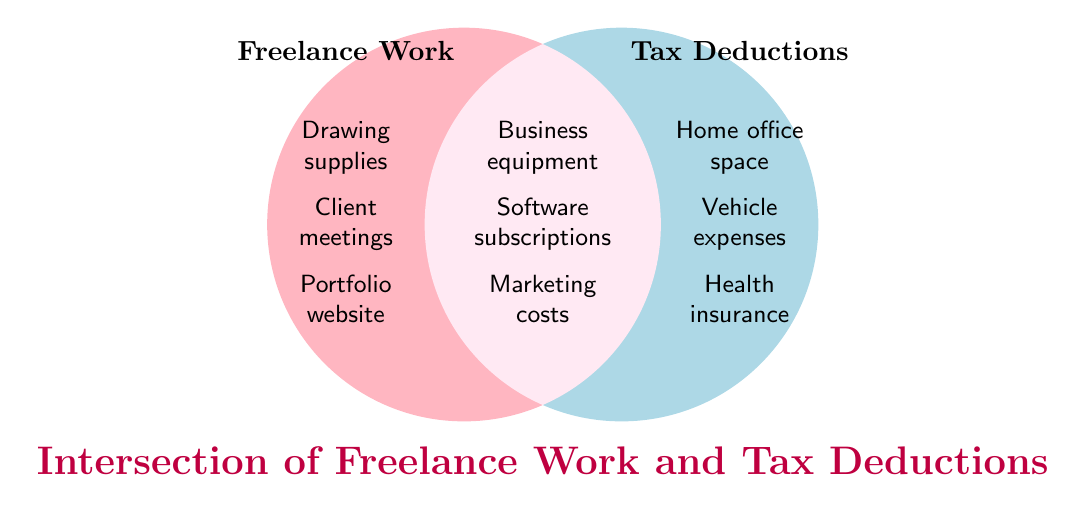What is the title of the figure? The title of the figure appears in bold and is located towards the bottom of the diagram. It reads "Intersection of Freelance Work and Tax Deductions."
Answer: Intersection of Freelance Work and Tax Deductions Which items are exclusive to Freelance Work? Items exclusive to Freelance Work are those that appear only inside the left circle. They are "Drawing supplies," "Client meetings," and "Portfolio website."
Answer: Drawing supplies, Client meetings, Portfolio website Which items belong to both Freelance Work and Tax Deductions? Items that belong to both Freelance Work and Tax Deductions appear in the overlapping section of the two circles. They are "Business equipment," "Software subscriptions," and "Marketing costs."
Answer: Business equipment, Software subscriptions, Marketing costs How many items are there in the Tax Deductions circle excluding the intersection? Count the items only in the right circle, excluding those in the overlapping section. There are three items: "Home office space," "Vehicle expenses," and "Health insurance."
Answer: 3 Compare the number of unique items in Freelance Work and Tax Deductions. Which has more? Count the unique items in each circle; Freelance Work has three ("Drawing supplies," "Client meetings," "Portfolio website") and Tax Deductions also have three ("Home office space," "Vehicle expenses," "Health insurance"). They have the same number of unique items.
Answer: Same Which category includes "Home office space"? "Home office space" is listed under the Tax Deductions category, visible solely in the right circle.
Answer: Tax Deductions What visual element is used to represent Freelance Work? The Freelance Work category is represented by a pink-colored circle on the left side of the Venn diagram.
Answer: Pink-colored circle on the left Identify an item that could be deducted on taxes for professional development. "Business equipment" can be related to professional development and it appears in the intersection of both Freelance Work and Tax Deductions.
Answer: Business equipment How many items are there in total across all sections of the Venn diagram? Sum the items in Freelance Work (3), Tax Deductions (3), and Intersection (3). The total number is 3 + 3 + 3 = 9.
Answer: 9 